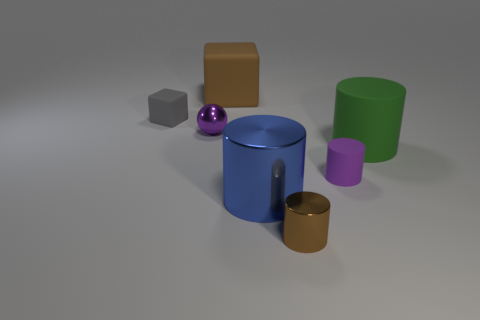Subtract 1 cylinders. How many cylinders are left? 3 Add 1 blue metallic cylinders. How many objects exist? 8 Subtract all blocks. How many objects are left? 5 Subtract 0 yellow cylinders. How many objects are left? 7 Subtract all small gray rubber cubes. Subtract all small gray blocks. How many objects are left? 5 Add 3 blue metal objects. How many blue metal objects are left? 4 Add 3 small purple shiny spheres. How many small purple shiny spheres exist? 4 